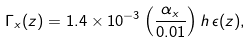<formula> <loc_0><loc_0><loc_500><loc_500>\Gamma _ { x } ( z ) = 1 . 4 \times 1 0 ^ { - 3 } \left ( \frac { \alpha _ { x } } { 0 . 0 1 } \right ) h \, \epsilon ( z ) ,</formula> 